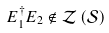Convert formula to latex. <formula><loc_0><loc_0><loc_500><loc_500>E _ { 1 } ^ { \dagger } E _ { 2 } \notin { \mathcal { Z } } \left ( { \mathcal { S } } \right )</formula> 